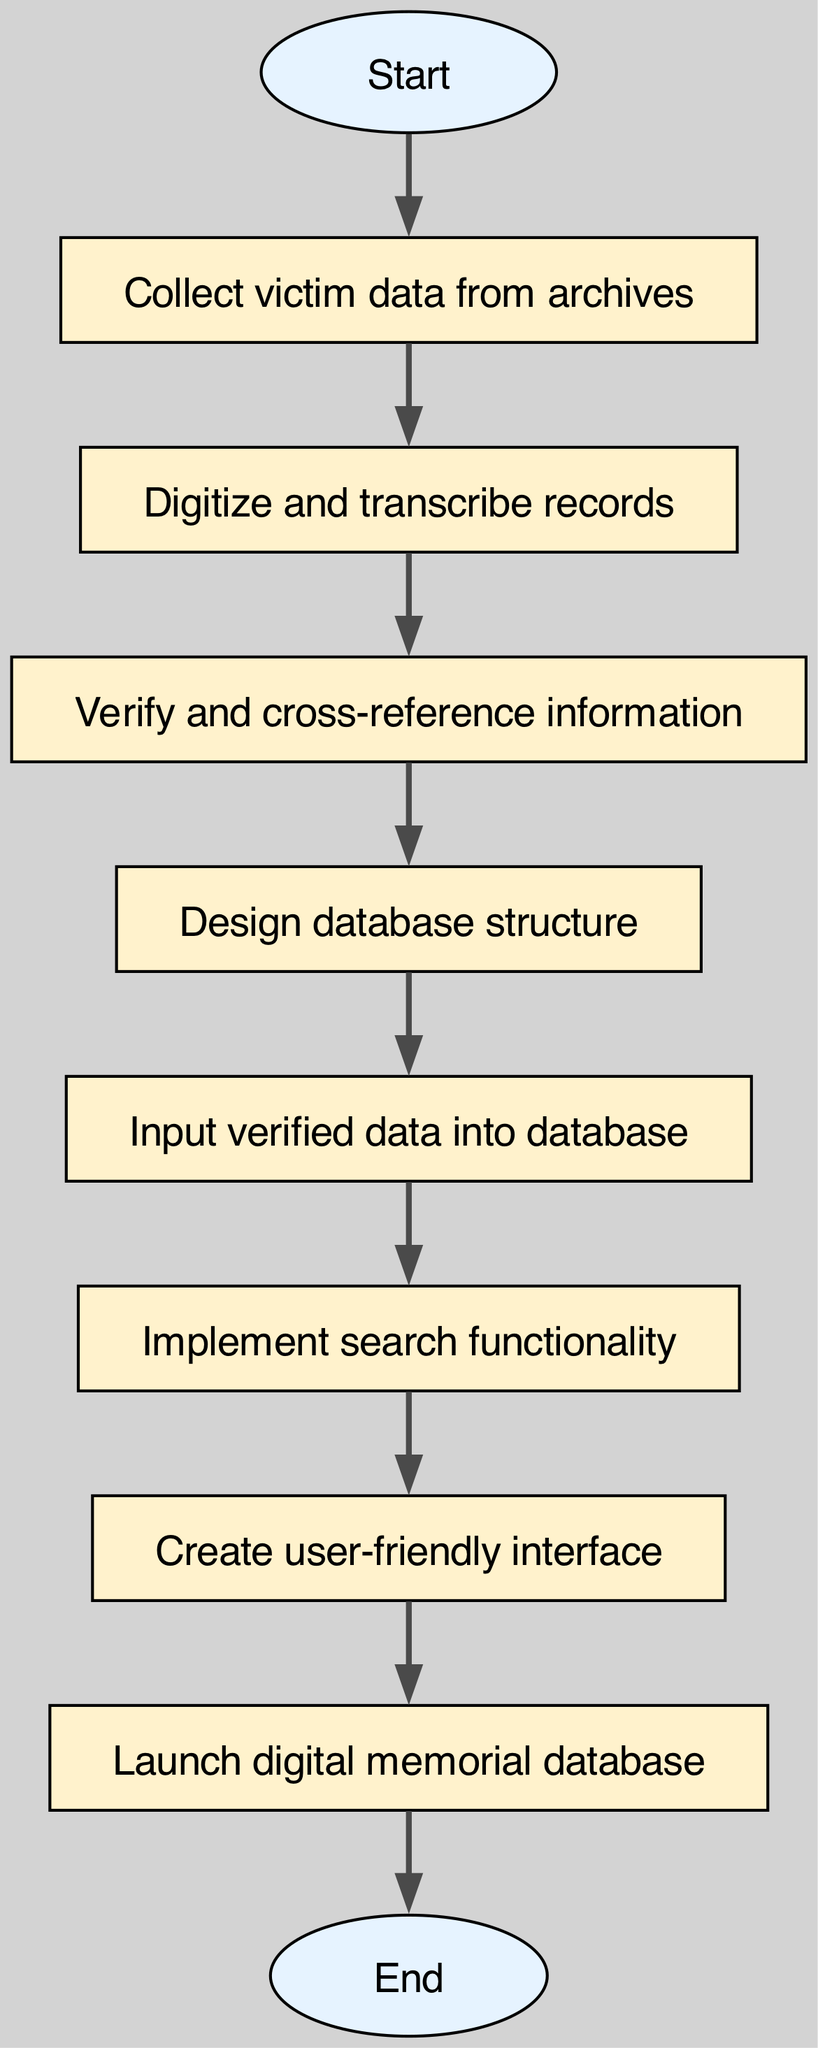What is the first step in the flowchart? The first step in the flowchart is labeled "Start." According to the flow of the diagram, it marks the initiation of the process to create the digital memorial database.
Answer: Start How many nodes are present in the diagram? By counting all the distinct elements in the flowchart, we find a total of ten nodes, including both the starting and ending points.
Answer: Ten Which step comes directly after verifying information? After "Verify and cross-reference information," the next step indicated in the flow is "Design database structure." This follows logically in the process.
Answer: Design database structure What type of functionality is implemented before creating a user-friendly interface? The flowchart indicates that "Implement search functionality" is the step that occurs just before "Create user-friendly interface," demonstrating the sequence of actions.
Answer: Implement search functionality How many edges connect the nodes in the diagram? By reviewing the connections between nodes in the diagram, we can see that there are nine edges that show the flow and relationships between the different steps.
Answer: Nine What is the last step in the process? The end of the flowchart indicates the final step is "End," signifying the completion of the process for creating the digital memorial database.
Answer: End Which node provides the data to be added to the database? The node "Input verified data into database" shows where the verified information collected and processed earlier is entered into the database, indicating its role in the flow.
Answer: Input verified data into database What must be done after designing the database structure? Following the design of the database structure, the next action is to "Input verified data into database," which logically follows in the dependency of the steps stated in the diagram.
Answer: Input verified data into database Which part of the flowchart outlines the creation of the final product? The step "Launch digital memorial database" outlines the culmination of the process, as it represents the actual deployment of the created database after all prior steps are completed.
Answer: Launch digital memorial database 